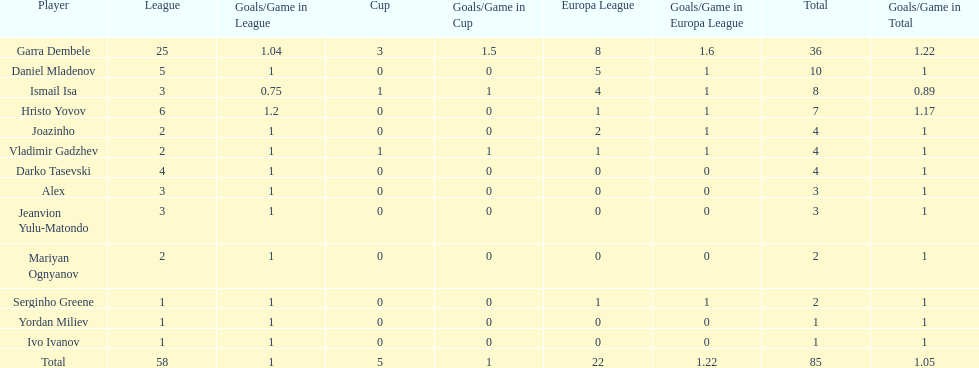How many players did not score a goal in cup play? 10. 